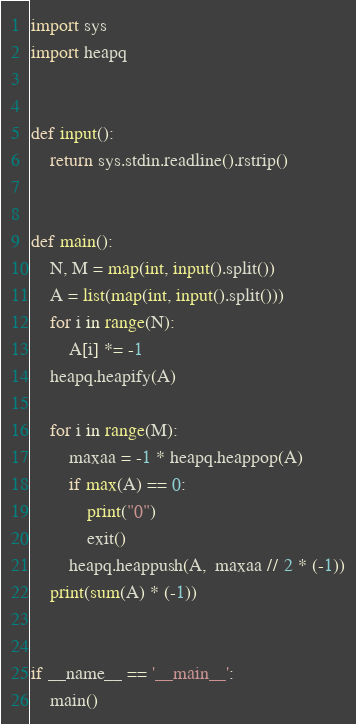<code> <loc_0><loc_0><loc_500><loc_500><_Python_>import sys
import heapq


def input():
    return sys.stdin.readline().rstrip()


def main():
    N, M = map(int, input().split())
    A = list(map(int, input().split()))
    for i in range(N):
        A[i] *= -1
    heapq.heapify(A)

    for i in range(M):
        maxaa = -1 * heapq.heappop(A)
        if max(A) == 0:
            print("0")
            exit()
        heapq.heappush(A,  maxaa // 2 * (-1))
    print(sum(A) * (-1))


if __name__ == '__main__':
    main()
</code> 